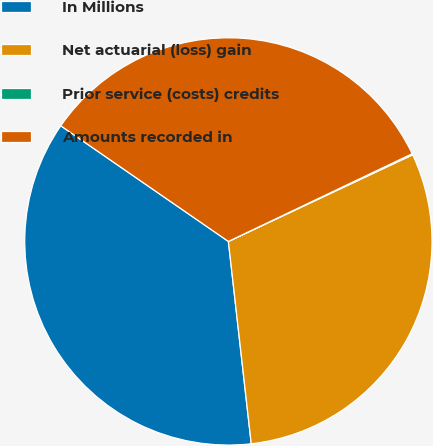<chart> <loc_0><loc_0><loc_500><loc_500><pie_chart><fcel>In Millions<fcel>Net actuarial (loss) gain<fcel>Prior service (costs) credits<fcel>Amounts recorded in<nl><fcel>36.4%<fcel>30.2%<fcel>0.09%<fcel>33.3%<nl></chart> 